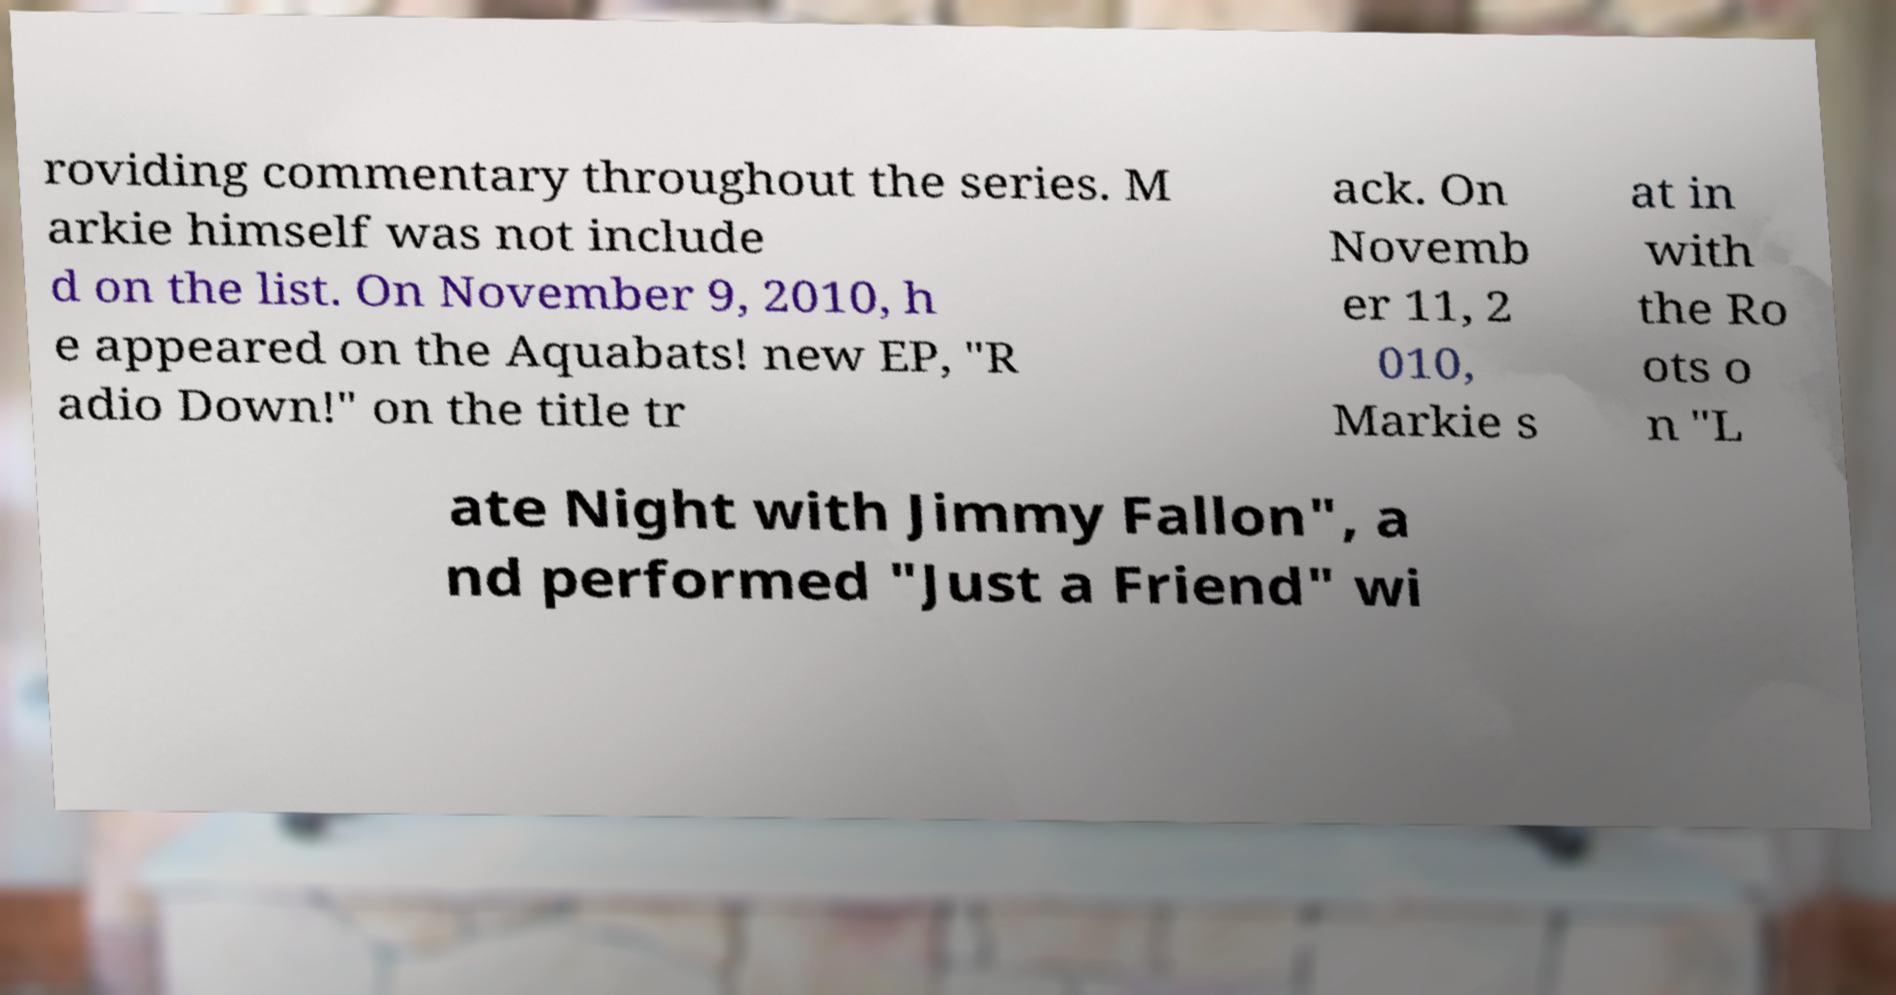For documentation purposes, I need the text within this image transcribed. Could you provide that? roviding commentary throughout the series. M arkie himself was not include d on the list. On November 9, 2010, h e appeared on the Aquabats! new EP, "R adio Down!" on the title tr ack. On Novemb er 11, 2 010, Markie s at in with the Ro ots o n "L ate Night with Jimmy Fallon", a nd performed "Just a Friend" wi 